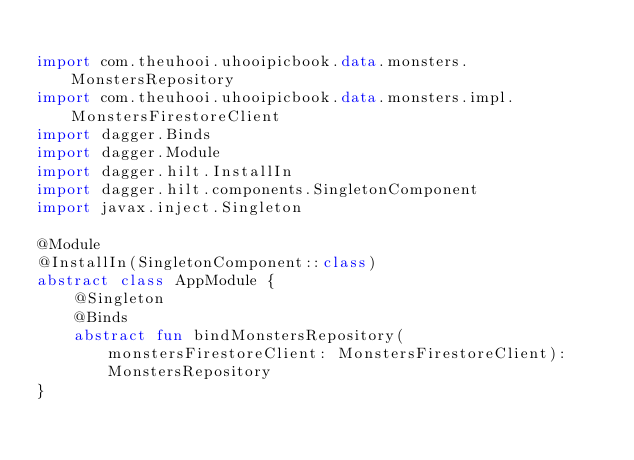Convert code to text. <code><loc_0><loc_0><loc_500><loc_500><_Kotlin_>
import com.theuhooi.uhooipicbook.data.monsters.MonstersRepository
import com.theuhooi.uhooipicbook.data.monsters.impl.MonstersFirestoreClient
import dagger.Binds
import dagger.Module
import dagger.hilt.InstallIn
import dagger.hilt.components.SingletonComponent
import javax.inject.Singleton

@Module
@InstallIn(SingletonComponent::class)
abstract class AppModule {
    @Singleton
    @Binds
    abstract fun bindMonstersRepository(monstersFirestoreClient: MonstersFirestoreClient): MonstersRepository
}
</code> 